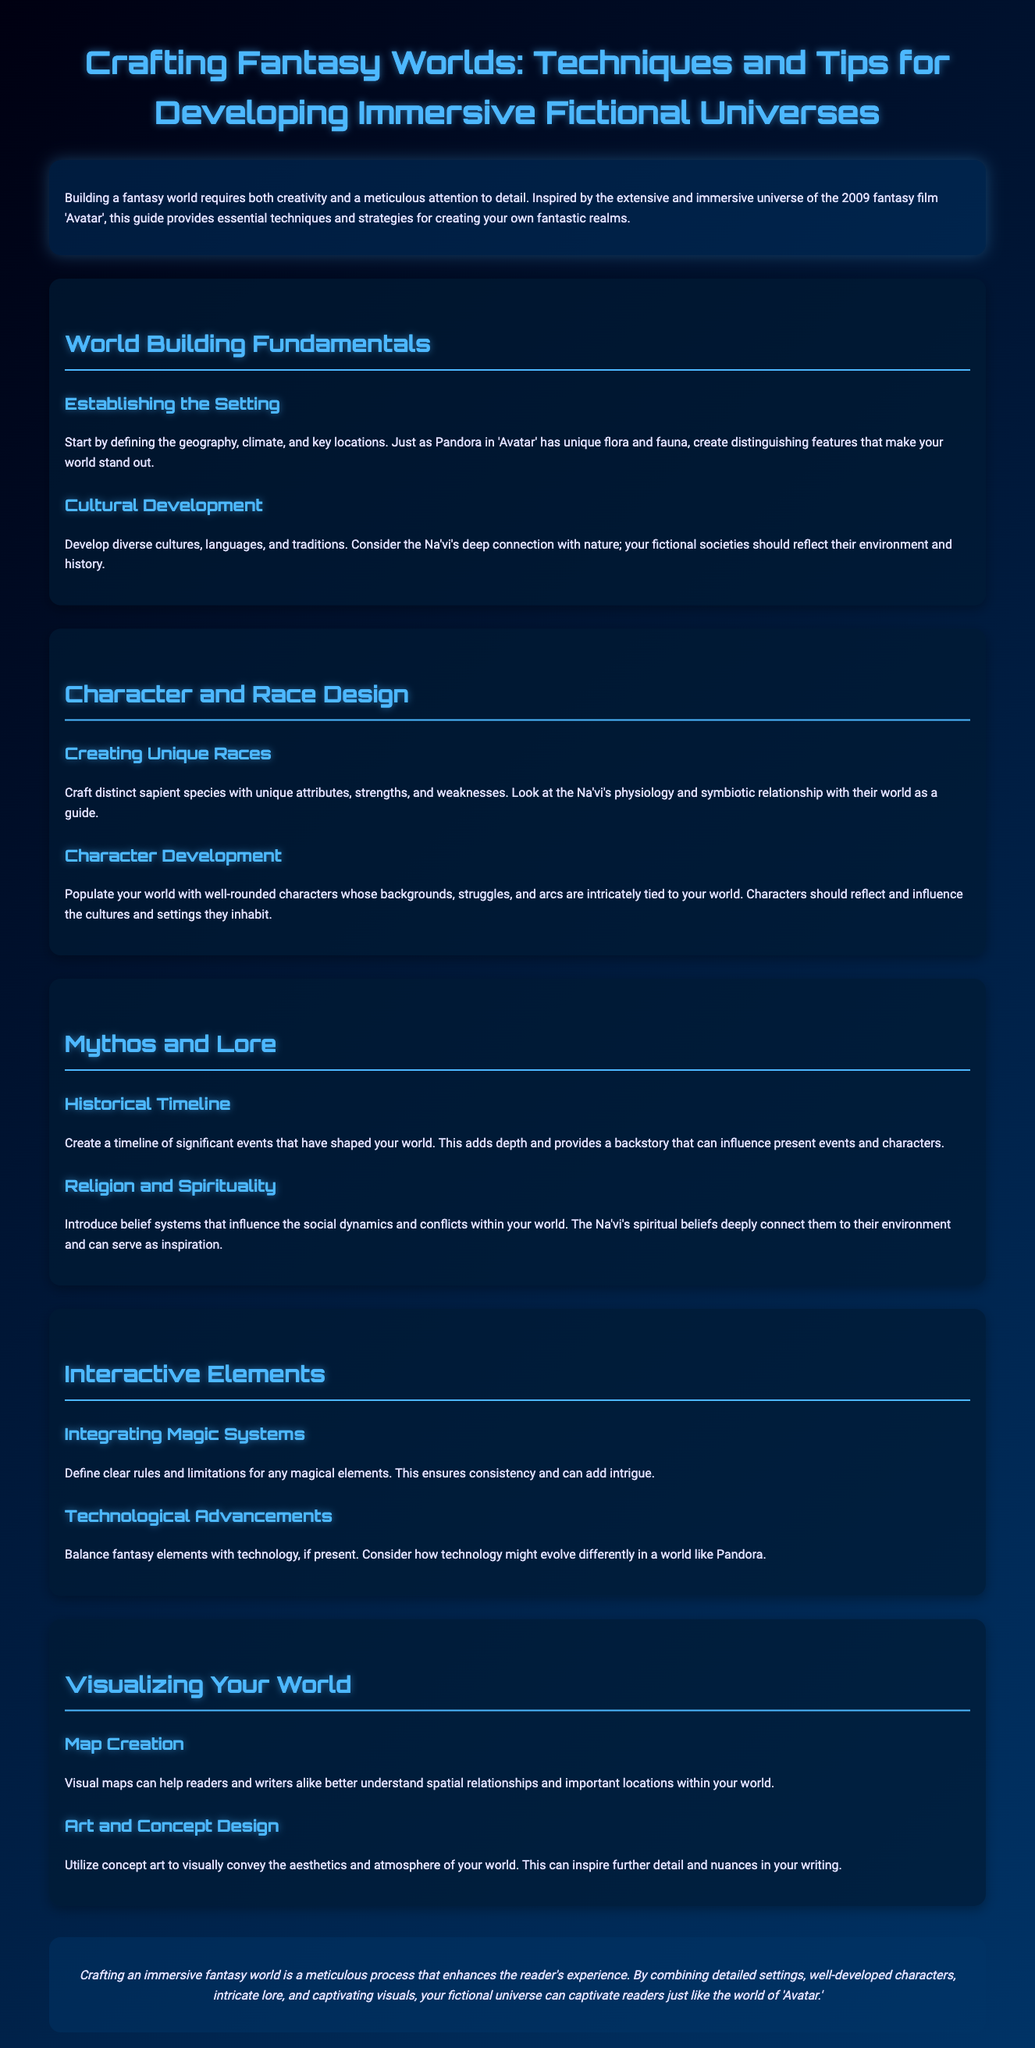What is the title of the whitepaper? The title is specified at the beginning of the document, highlighting its focus on creating fantasy worlds.
Answer: Crafting Fantasy Worlds: Techniques and Tips for Developing Immersive Fictional Universes What film inspired this guide? The document mentions that it is inspired by the universe of a specific fantasy film, which sets the context for its advice.
Answer: Avatar What section covers character development? The section specifically dealing with creating and developing characters is clearly defined in the document.
Answer: Character and Race Design What unique species are discussed as a guide for creation? The guide references a specific species known for their unique attributes, serving as an example for world builders.
Answer: Na'vi What is one method suggested for visualizing a fantasy world? The document offers a technique for helping readers and writers understand the layout of the fantasy world.
Answer: Map Creation How should belief systems affect world dynamics? The guide emphasizes the influence of spirituality on social structures and conflicts within the narrative.
Answer: Influence the social dynamics and conflicts What is a key element to include when establishing a setting? The document suggests various aspects to define, which will contribute to a distinctive setting in a fantasy world.
Answer: Geography What type of art is recommended for conveying aesthetics? A specific approach to visually represent aspects of the world is mentioned, which can inspire further details in storytelling.
Answer: Concept art 